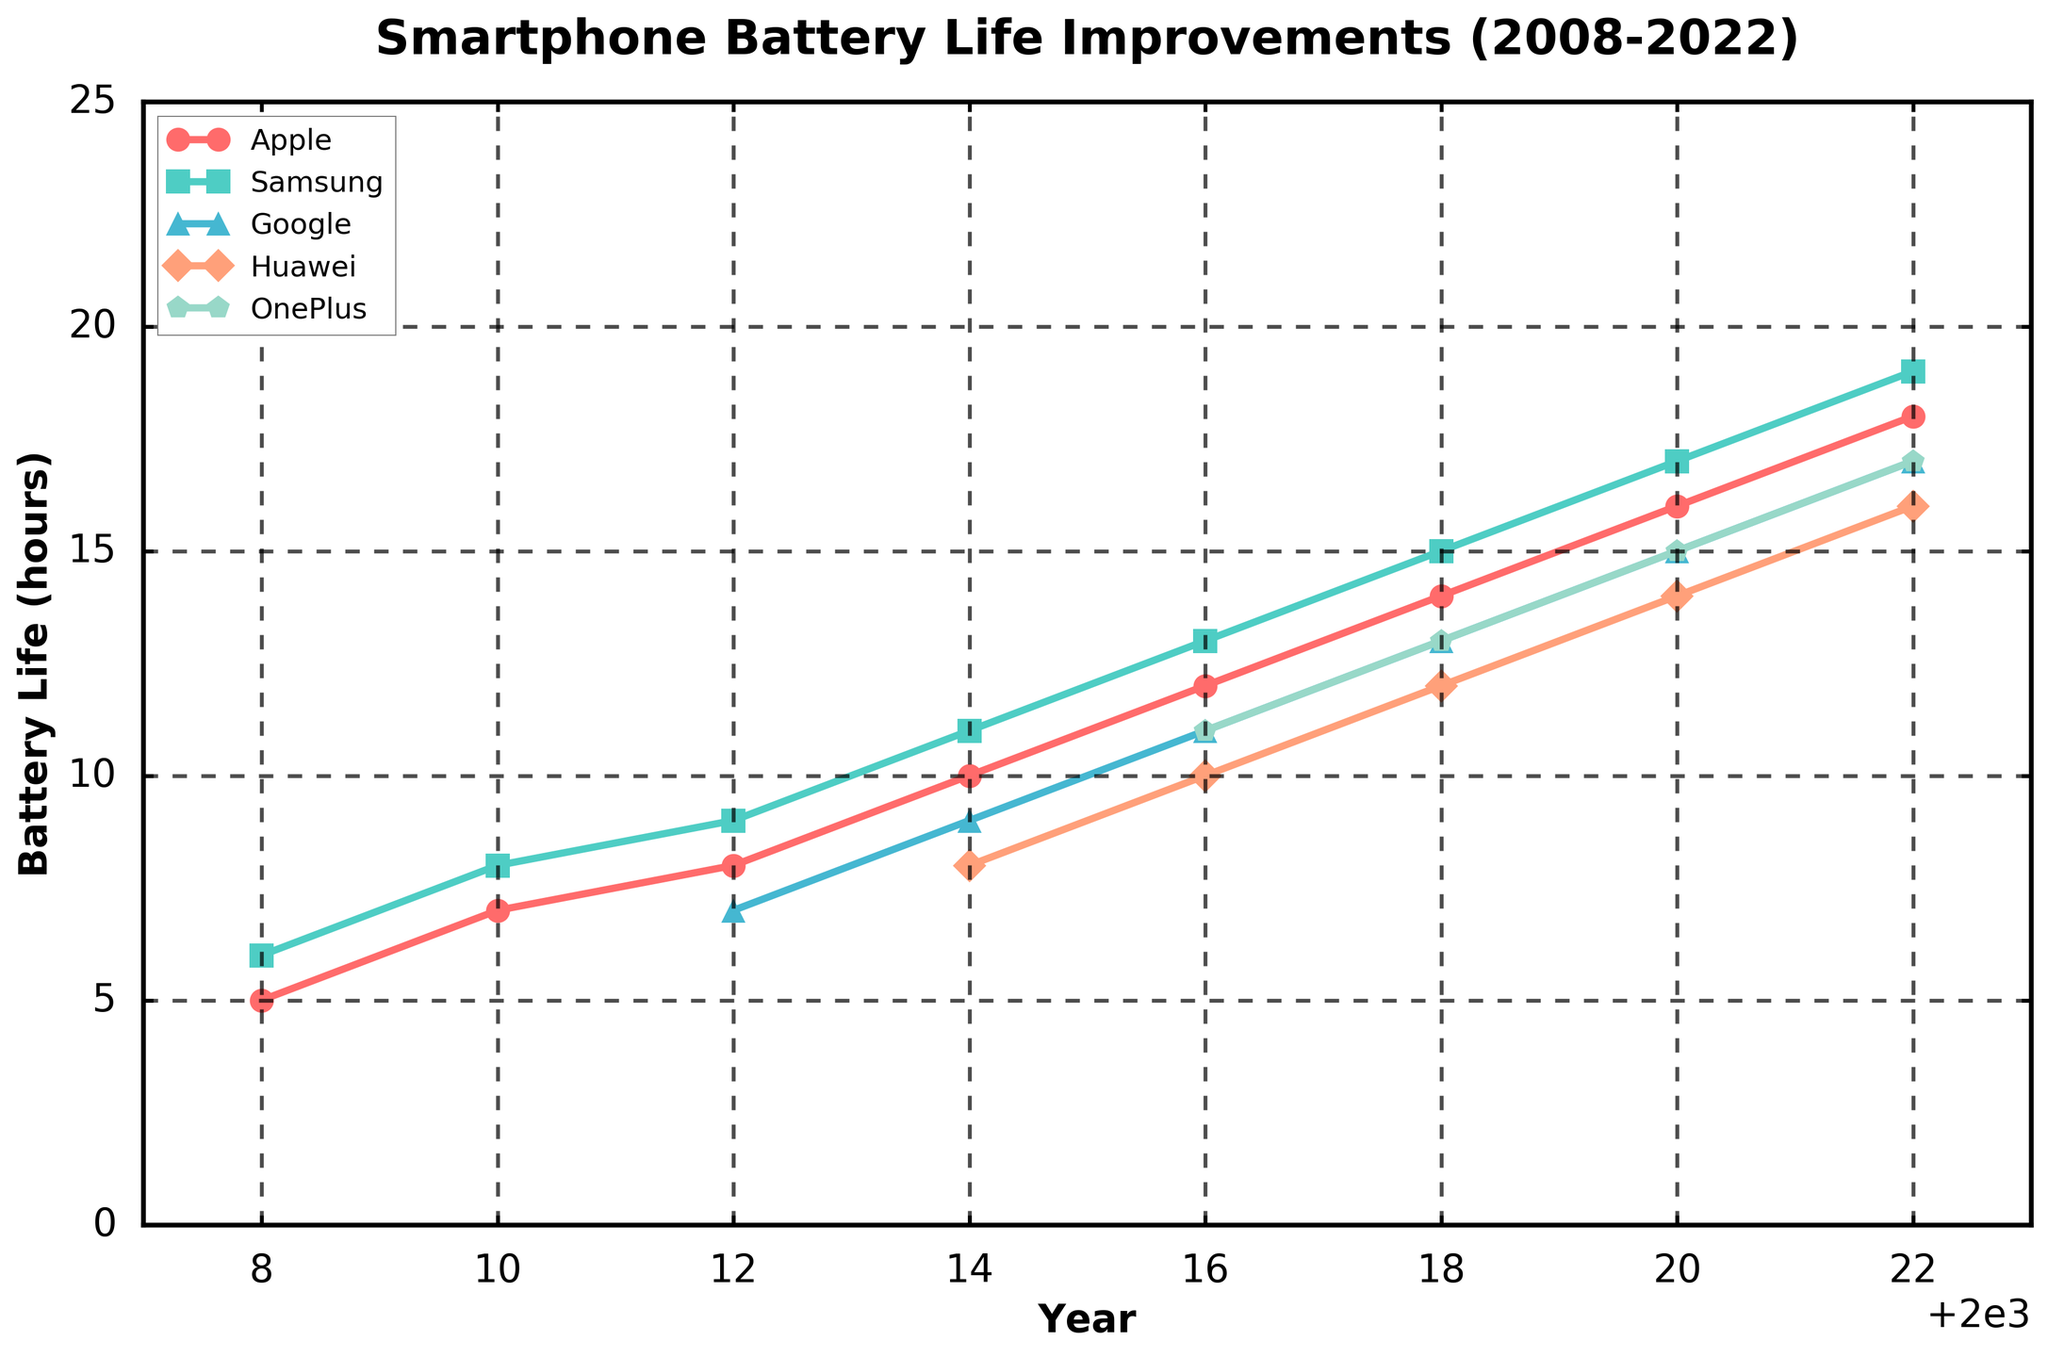How has Apple's battery life improved from 2008 to 2022? The figure shows the line representing Apple from 2008 to 2022. In 2008, battery life was 5 hours, and in 2022 it reached 18 hours. Subtracting the initial value from the final gives the improvement: 18 - 5 = 13 hours.
Answer: 13 hours Which manufacturer had the highest increase in battery life from 2010 to 2018? Check battery life values for 2010 and 2018 for all series. Apple's values go from 7 to 14, increasing by 7 hours; Samsung's values go from 8 to 15, increasing by 7 hours; and Google's values go from no data to 13; meanwhile, Huawei and OnePlus have no data for 2010. So, Apple and Samsung both have a 7-hour increase.
Answer: Apple and Samsung What is the average battery life improvement for all manufacturers between 2014 and 2022? Sum battery life differences between 2014 and 2022 for all manufacturers and divide by the number of manufacturers. Apple: (18-10), Samsung (19-11), Google (17-9), Huawei (16-8), and OnePlus (17-11). Total sum is (8+8+8+8+6) = 38. Average = 38 / 5 manufacturers = 7.6 hours.
Answer: 7.6 hours In which year did Google first show an increase in battery life? Google's data first appears in 2012 at 7 hours and increases in 2014 to 9 hours. Therefore, the year 2014 marks its first increase.
Answer: 2014 Between 2010 and 2020, which manufacturer showed the smallest overall improvement in battery life? Check values for 2010 and 2020: Apple (7 to 16), Samsung (8 to 17), Google (7 in 2012 to 15 in 2020), Huawei (8 in 2014 to 14 in 2020), OnePlus (11 in 2016 to 15 in 2020). Google shows an 8-hour increase, Huawei a 6-hour increase, so Huawei has the smallest overall improvement.
Answer: Huawei Which manufacturer has the steepest slope in their battery improvement trend from 2016 to 2018? Examine the slope of the line segments between 2016 to 2018, look at the changes: Apple (12 to 14), Samsung (13 to 15), Google (11 to 13), Huawei (10 to 12). The change for all is 2 hours, no steepest slope for this specific interval.
Answer: No steepest slope What color line represents Huawei's battery life improvements? Refer to the line colors in the chart. Huawei's line is represented with an orange color.
Answer: Orange If the data were extended to 2024, and assuming the same increment trend, what would be the estimated battery life for Samsung? Identify increments in Samsung’s battery life between intervals. The increments seem consistent (2 hours every 2 years from 2016 to 2022), so 19+2=21 hours by 2024.
Answer: 21 hours Based on the chart, which manufacturer had no data available before 2016 and what is its battery trend from 2016 onward? Look at the lines, OnePlus series data starts in 2016 at 11 hours, increasing consistently to 15 by 2020, then to 17 hours by 2022.
Answer: OnePlus, increasing trend Which manufacturer shows the most linear improvement in battery life across all years? By tracing each line and checking consistency in the slope, Samsung shows the most linear improvement from 2008 at 6 hours to 19 hours in 2022.
Answer: Samsung 